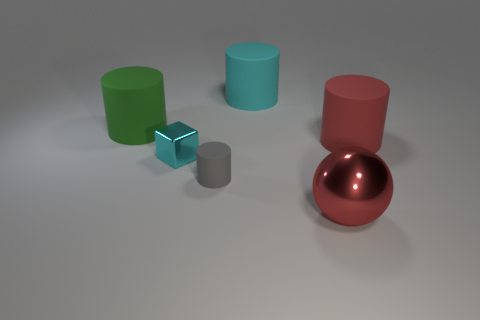There is a cylinder in front of the large cylinder that is in front of the green cylinder; what color is it?
Your answer should be very brief. Gray. Is the number of big shiny things less than the number of small green balls?
Provide a succinct answer. No. How many gray things are the same shape as the small cyan metallic object?
Offer a terse response. 0. The other thing that is the same size as the gray rubber object is what color?
Provide a succinct answer. Cyan. Are there the same number of red matte objects in front of the tiny metallic block and large rubber objects that are to the right of the large red sphere?
Provide a short and direct response. No. Are there any cyan matte blocks of the same size as the cyan metal thing?
Make the answer very short. No. What size is the ball?
Ensure brevity in your answer.  Large. Are there an equal number of gray cylinders in front of the gray cylinder and rubber things?
Your answer should be very brief. No. How many other things are there of the same color as the shiny cube?
Your response must be concise. 1. What color is the thing that is on the right side of the gray cylinder and in front of the cube?
Your response must be concise. Red. 